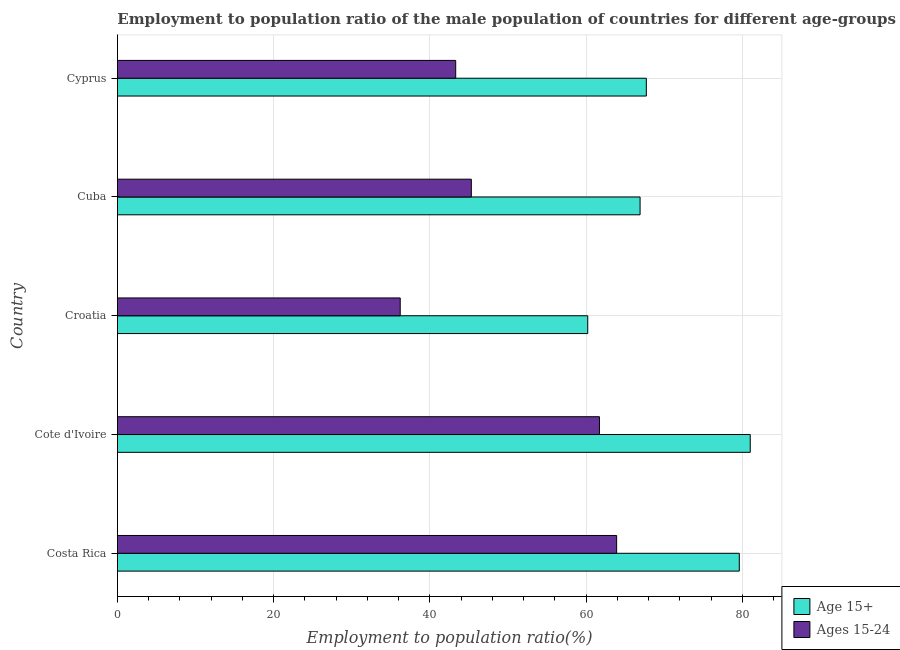Are the number of bars per tick equal to the number of legend labels?
Offer a terse response. Yes. How many bars are there on the 3rd tick from the top?
Give a very brief answer. 2. What is the label of the 1st group of bars from the top?
Provide a short and direct response. Cyprus. What is the employment to population ratio(age 15-24) in Cuba?
Your answer should be compact. 45.3. Across all countries, what is the maximum employment to population ratio(age 15-24)?
Keep it short and to the point. 63.9. Across all countries, what is the minimum employment to population ratio(age 15-24)?
Your answer should be very brief. 36.2. In which country was the employment to population ratio(age 15+) minimum?
Provide a succinct answer. Croatia. What is the total employment to population ratio(age 15-24) in the graph?
Provide a short and direct response. 250.4. What is the difference between the employment to population ratio(age 15-24) in Costa Rica and that in Cyprus?
Offer a very short reply. 20.6. What is the difference between the employment to population ratio(age 15-24) in Croatia and the employment to population ratio(age 15+) in Cyprus?
Ensure brevity in your answer.  -31.5. What is the average employment to population ratio(age 15+) per country?
Make the answer very short. 71.08. What is the difference between the employment to population ratio(age 15-24) and employment to population ratio(age 15+) in Cote d'Ivoire?
Your answer should be compact. -19.3. What is the ratio of the employment to population ratio(age 15-24) in Cote d'Ivoire to that in Cuba?
Provide a succinct answer. 1.36. What is the difference between the highest and the lowest employment to population ratio(age 15-24)?
Offer a very short reply. 27.7. In how many countries, is the employment to population ratio(age 15-24) greater than the average employment to population ratio(age 15-24) taken over all countries?
Offer a terse response. 2. What does the 2nd bar from the top in Costa Rica represents?
Keep it short and to the point. Age 15+. What does the 2nd bar from the bottom in Cote d'Ivoire represents?
Keep it short and to the point. Ages 15-24. Are all the bars in the graph horizontal?
Offer a very short reply. Yes. How many countries are there in the graph?
Ensure brevity in your answer.  5. What is the difference between two consecutive major ticks on the X-axis?
Provide a short and direct response. 20. Where does the legend appear in the graph?
Your answer should be compact. Bottom right. How many legend labels are there?
Your answer should be compact. 2. How are the legend labels stacked?
Provide a succinct answer. Vertical. What is the title of the graph?
Your answer should be compact. Employment to population ratio of the male population of countries for different age-groups. Does "Savings" appear as one of the legend labels in the graph?
Your answer should be compact. No. What is the Employment to population ratio(%) in Age 15+ in Costa Rica?
Your answer should be very brief. 79.6. What is the Employment to population ratio(%) of Ages 15-24 in Costa Rica?
Your response must be concise. 63.9. What is the Employment to population ratio(%) in Ages 15-24 in Cote d'Ivoire?
Provide a succinct answer. 61.7. What is the Employment to population ratio(%) in Age 15+ in Croatia?
Offer a terse response. 60.2. What is the Employment to population ratio(%) of Ages 15-24 in Croatia?
Give a very brief answer. 36.2. What is the Employment to population ratio(%) in Age 15+ in Cuba?
Your answer should be compact. 66.9. What is the Employment to population ratio(%) of Ages 15-24 in Cuba?
Make the answer very short. 45.3. What is the Employment to population ratio(%) of Age 15+ in Cyprus?
Ensure brevity in your answer.  67.7. What is the Employment to population ratio(%) of Ages 15-24 in Cyprus?
Keep it short and to the point. 43.3. Across all countries, what is the maximum Employment to population ratio(%) of Ages 15-24?
Provide a succinct answer. 63.9. Across all countries, what is the minimum Employment to population ratio(%) in Age 15+?
Your response must be concise. 60.2. Across all countries, what is the minimum Employment to population ratio(%) in Ages 15-24?
Ensure brevity in your answer.  36.2. What is the total Employment to population ratio(%) in Age 15+ in the graph?
Offer a terse response. 355.4. What is the total Employment to population ratio(%) of Ages 15-24 in the graph?
Offer a terse response. 250.4. What is the difference between the Employment to population ratio(%) of Ages 15-24 in Costa Rica and that in Cote d'Ivoire?
Your answer should be very brief. 2.2. What is the difference between the Employment to population ratio(%) of Age 15+ in Costa Rica and that in Croatia?
Your answer should be very brief. 19.4. What is the difference between the Employment to population ratio(%) of Ages 15-24 in Costa Rica and that in Croatia?
Provide a short and direct response. 27.7. What is the difference between the Employment to population ratio(%) in Ages 15-24 in Costa Rica and that in Cyprus?
Your response must be concise. 20.6. What is the difference between the Employment to population ratio(%) of Age 15+ in Cote d'Ivoire and that in Croatia?
Make the answer very short. 20.8. What is the difference between the Employment to population ratio(%) of Ages 15-24 in Cote d'Ivoire and that in Croatia?
Ensure brevity in your answer.  25.5. What is the difference between the Employment to population ratio(%) in Age 15+ in Cote d'Ivoire and that in Cyprus?
Offer a very short reply. 13.3. What is the difference between the Employment to population ratio(%) of Age 15+ in Croatia and that in Cuba?
Offer a terse response. -6.7. What is the difference between the Employment to population ratio(%) in Ages 15-24 in Croatia and that in Cuba?
Offer a terse response. -9.1. What is the difference between the Employment to population ratio(%) in Age 15+ in Croatia and that in Cyprus?
Your response must be concise. -7.5. What is the difference between the Employment to population ratio(%) of Ages 15-24 in Croatia and that in Cyprus?
Offer a very short reply. -7.1. What is the difference between the Employment to population ratio(%) in Age 15+ in Cuba and that in Cyprus?
Keep it short and to the point. -0.8. What is the difference between the Employment to population ratio(%) in Age 15+ in Costa Rica and the Employment to population ratio(%) in Ages 15-24 in Cote d'Ivoire?
Ensure brevity in your answer.  17.9. What is the difference between the Employment to population ratio(%) in Age 15+ in Costa Rica and the Employment to population ratio(%) in Ages 15-24 in Croatia?
Offer a terse response. 43.4. What is the difference between the Employment to population ratio(%) of Age 15+ in Costa Rica and the Employment to population ratio(%) of Ages 15-24 in Cuba?
Your answer should be compact. 34.3. What is the difference between the Employment to population ratio(%) in Age 15+ in Costa Rica and the Employment to population ratio(%) in Ages 15-24 in Cyprus?
Offer a very short reply. 36.3. What is the difference between the Employment to population ratio(%) of Age 15+ in Cote d'Ivoire and the Employment to population ratio(%) of Ages 15-24 in Croatia?
Keep it short and to the point. 44.8. What is the difference between the Employment to population ratio(%) of Age 15+ in Cote d'Ivoire and the Employment to population ratio(%) of Ages 15-24 in Cuba?
Provide a short and direct response. 35.7. What is the difference between the Employment to population ratio(%) in Age 15+ in Cote d'Ivoire and the Employment to population ratio(%) in Ages 15-24 in Cyprus?
Make the answer very short. 37.7. What is the difference between the Employment to population ratio(%) of Age 15+ in Croatia and the Employment to population ratio(%) of Ages 15-24 in Cuba?
Offer a very short reply. 14.9. What is the difference between the Employment to population ratio(%) of Age 15+ in Croatia and the Employment to population ratio(%) of Ages 15-24 in Cyprus?
Make the answer very short. 16.9. What is the difference between the Employment to population ratio(%) in Age 15+ in Cuba and the Employment to population ratio(%) in Ages 15-24 in Cyprus?
Offer a very short reply. 23.6. What is the average Employment to population ratio(%) of Age 15+ per country?
Your response must be concise. 71.08. What is the average Employment to population ratio(%) in Ages 15-24 per country?
Your answer should be compact. 50.08. What is the difference between the Employment to population ratio(%) of Age 15+ and Employment to population ratio(%) of Ages 15-24 in Cote d'Ivoire?
Your answer should be compact. 19.3. What is the difference between the Employment to population ratio(%) of Age 15+ and Employment to population ratio(%) of Ages 15-24 in Croatia?
Keep it short and to the point. 24. What is the difference between the Employment to population ratio(%) of Age 15+ and Employment to population ratio(%) of Ages 15-24 in Cuba?
Your answer should be very brief. 21.6. What is the difference between the Employment to population ratio(%) of Age 15+ and Employment to population ratio(%) of Ages 15-24 in Cyprus?
Provide a succinct answer. 24.4. What is the ratio of the Employment to population ratio(%) of Age 15+ in Costa Rica to that in Cote d'Ivoire?
Your answer should be very brief. 0.98. What is the ratio of the Employment to population ratio(%) of Ages 15-24 in Costa Rica to that in Cote d'Ivoire?
Make the answer very short. 1.04. What is the ratio of the Employment to population ratio(%) in Age 15+ in Costa Rica to that in Croatia?
Ensure brevity in your answer.  1.32. What is the ratio of the Employment to population ratio(%) of Ages 15-24 in Costa Rica to that in Croatia?
Keep it short and to the point. 1.77. What is the ratio of the Employment to population ratio(%) of Age 15+ in Costa Rica to that in Cuba?
Offer a very short reply. 1.19. What is the ratio of the Employment to population ratio(%) in Ages 15-24 in Costa Rica to that in Cuba?
Give a very brief answer. 1.41. What is the ratio of the Employment to population ratio(%) of Age 15+ in Costa Rica to that in Cyprus?
Provide a succinct answer. 1.18. What is the ratio of the Employment to population ratio(%) of Ages 15-24 in Costa Rica to that in Cyprus?
Your answer should be very brief. 1.48. What is the ratio of the Employment to population ratio(%) in Age 15+ in Cote d'Ivoire to that in Croatia?
Your response must be concise. 1.35. What is the ratio of the Employment to population ratio(%) in Ages 15-24 in Cote d'Ivoire to that in Croatia?
Your answer should be very brief. 1.7. What is the ratio of the Employment to population ratio(%) in Age 15+ in Cote d'Ivoire to that in Cuba?
Make the answer very short. 1.21. What is the ratio of the Employment to population ratio(%) in Ages 15-24 in Cote d'Ivoire to that in Cuba?
Offer a terse response. 1.36. What is the ratio of the Employment to population ratio(%) in Age 15+ in Cote d'Ivoire to that in Cyprus?
Your response must be concise. 1.2. What is the ratio of the Employment to population ratio(%) in Ages 15-24 in Cote d'Ivoire to that in Cyprus?
Provide a succinct answer. 1.42. What is the ratio of the Employment to population ratio(%) of Age 15+ in Croatia to that in Cuba?
Ensure brevity in your answer.  0.9. What is the ratio of the Employment to population ratio(%) in Ages 15-24 in Croatia to that in Cuba?
Offer a terse response. 0.8. What is the ratio of the Employment to population ratio(%) of Age 15+ in Croatia to that in Cyprus?
Make the answer very short. 0.89. What is the ratio of the Employment to population ratio(%) in Ages 15-24 in Croatia to that in Cyprus?
Provide a succinct answer. 0.84. What is the ratio of the Employment to population ratio(%) in Ages 15-24 in Cuba to that in Cyprus?
Your answer should be very brief. 1.05. What is the difference between the highest and the second highest Employment to population ratio(%) in Age 15+?
Provide a short and direct response. 1.4. What is the difference between the highest and the lowest Employment to population ratio(%) in Age 15+?
Make the answer very short. 20.8. What is the difference between the highest and the lowest Employment to population ratio(%) in Ages 15-24?
Your answer should be compact. 27.7. 